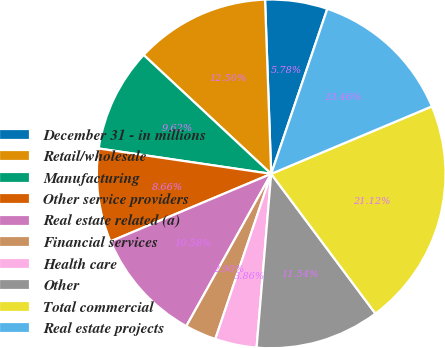<chart> <loc_0><loc_0><loc_500><loc_500><pie_chart><fcel>December 31 - in millions<fcel>Retail/wholesale<fcel>Manufacturing<fcel>Other service providers<fcel>Real estate related (a)<fcel>Financial services<fcel>Health care<fcel>Other<fcel>Total commercial<fcel>Real estate projects<nl><fcel>5.78%<fcel>12.5%<fcel>9.62%<fcel>8.66%<fcel>10.58%<fcel>2.9%<fcel>3.86%<fcel>11.54%<fcel>21.13%<fcel>13.46%<nl></chart> 